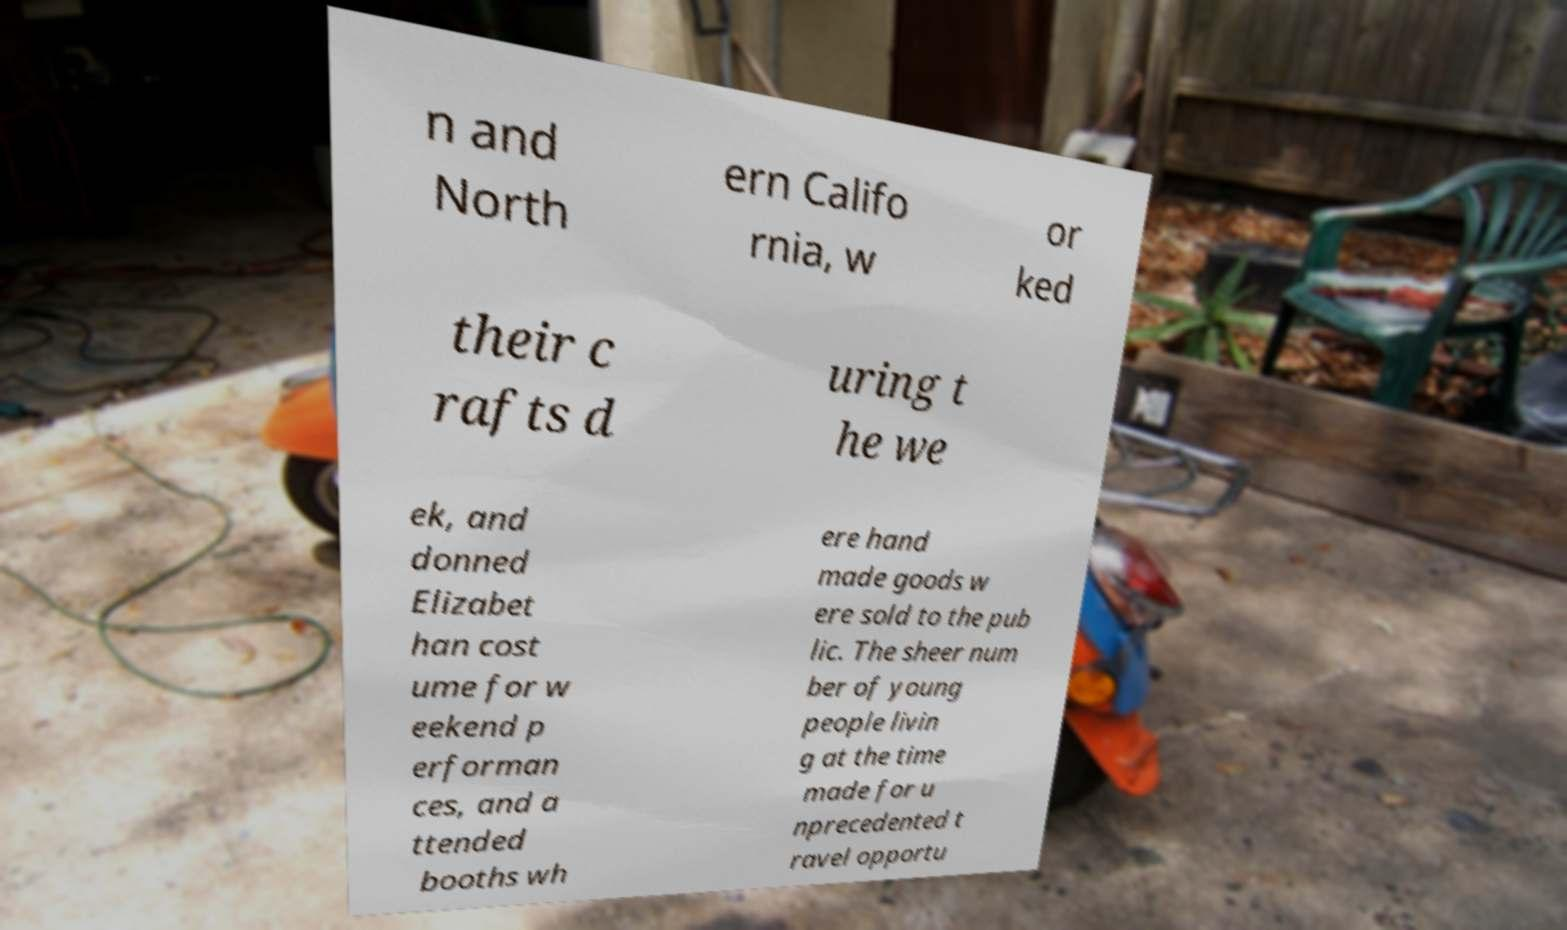There's text embedded in this image that I need extracted. Can you transcribe it verbatim? n and North ern Califo rnia, w or ked their c rafts d uring t he we ek, and donned Elizabet han cost ume for w eekend p erforman ces, and a ttended booths wh ere hand made goods w ere sold to the pub lic. The sheer num ber of young people livin g at the time made for u nprecedented t ravel opportu 